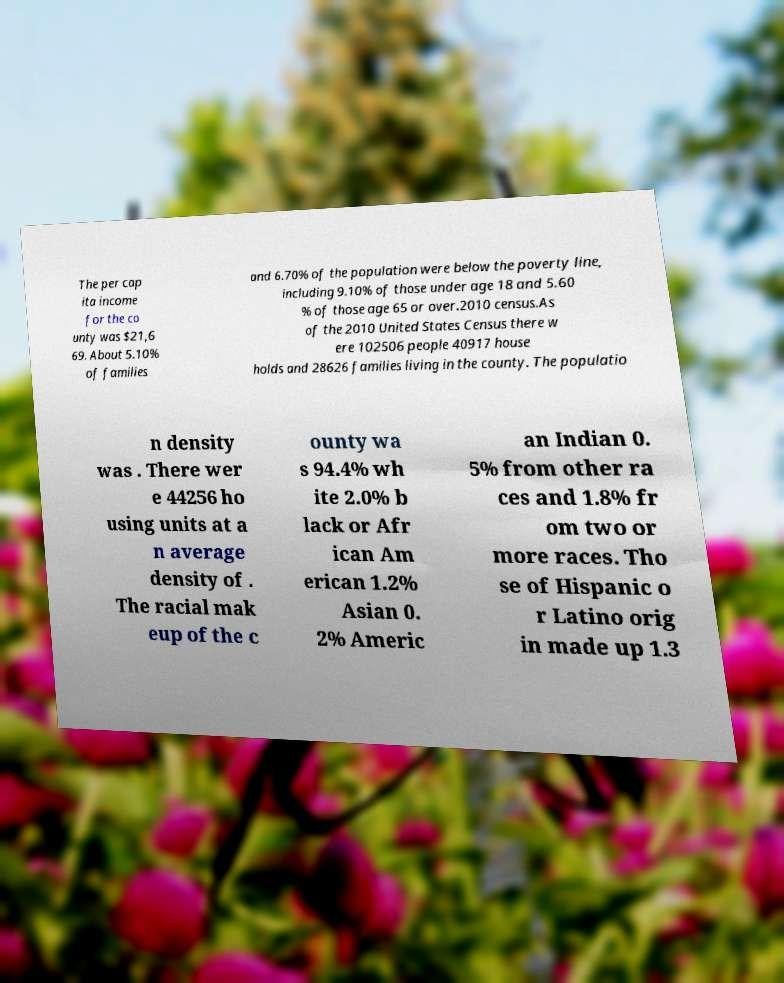Could you assist in decoding the text presented in this image and type it out clearly? The per cap ita income for the co unty was $21,6 69. About 5.10% of families and 6.70% of the population were below the poverty line, including 9.10% of those under age 18 and 5.60 % of those age 65 or over.2010 census.As of the 2010 United States Census there w ere 102506 people 40917 house holds and 28626 families living in the county. The populatio n density was . There wer e 44256 ho using units at a n average density of . The racial mak eup of the c ounty wa s 94.4% wh ite 2.0% b lack or Afr ican Am erican 1.2% Asian 0. 2% Americ an Indian 0. 5% from other ra ces and 1.8% fr om two or more races. Tho se of Hispanic o r Latino orig in made up 1.3 